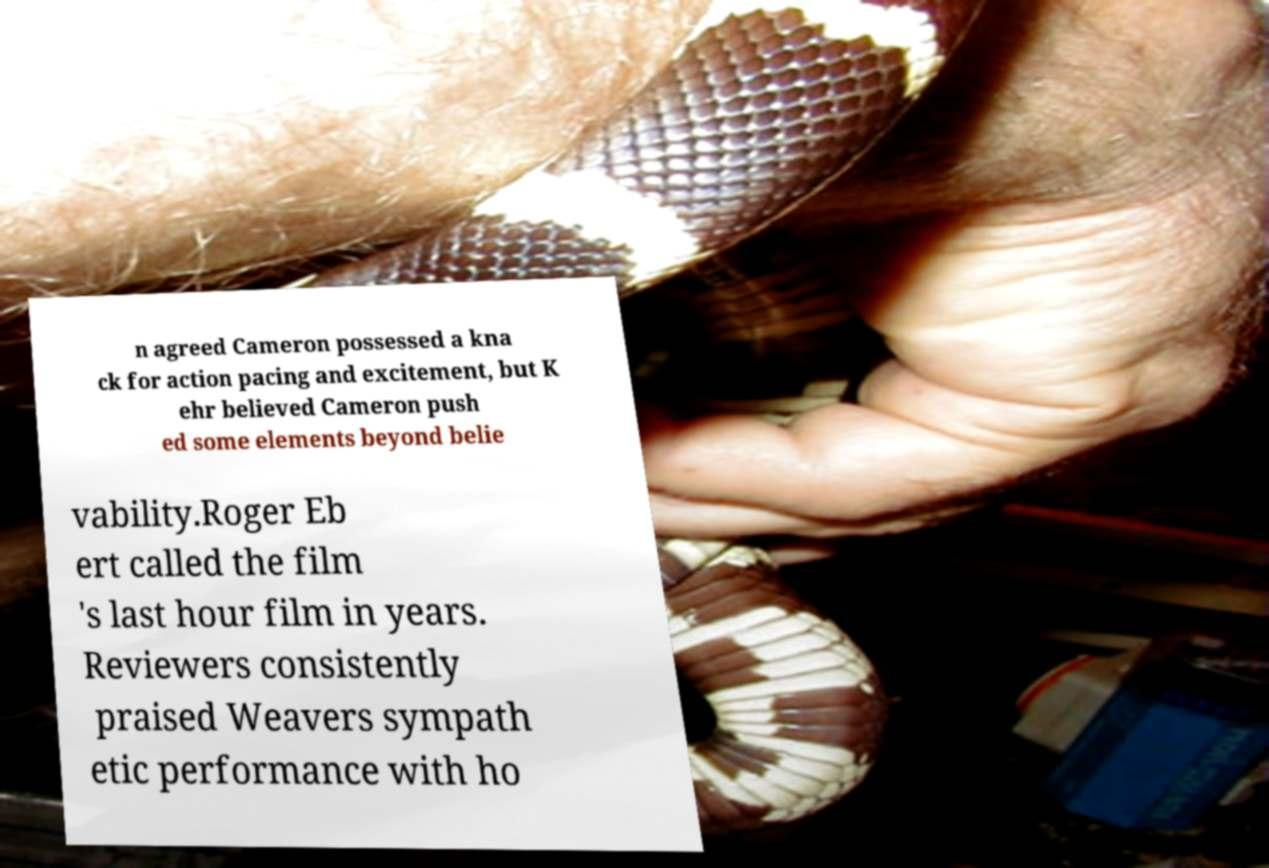There's text embedded in this image that I need extracted. Can you transcribe it verbatim? n agreed Cameron possessed a kna ck for action pacing and excitement, but K ehr believed Cameron push ed some elements beyond belie vability.Roger Eb ert called the film 's last hour film in years. Reviewers consistently praised Weavers sympath etic performance with ho 